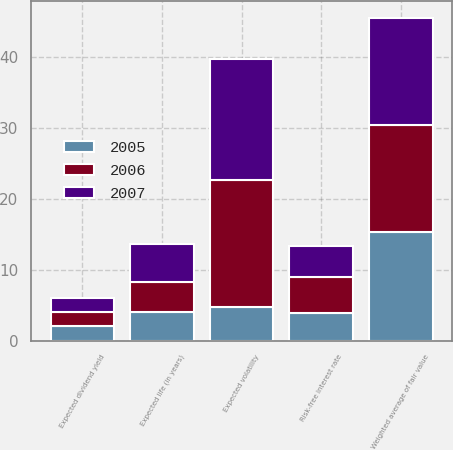<chart> <loc_0><loc_0><loc_500><loc_500><stacked_bar_chart><ecel><fcel>Weighted average of fair value<fcel>Expected dividend yield<fcel>Expected volatility<fcel>Risk-free interest rate<fcel>Expected life (in years)<nl><fcel>2007<fcel>15.15<fcel>2<fcel>17<fcel>4.42<fcel>5.4<nl><fcel>2006<fcel>15.02<fcel>2<fcel>18<fcel>4.95<fcel>4.1<nl><fcel>2005<fcel>15.33<fcel>2<fcel>4.685<fcel>3.95<fcel>4.1<nl></chart> 